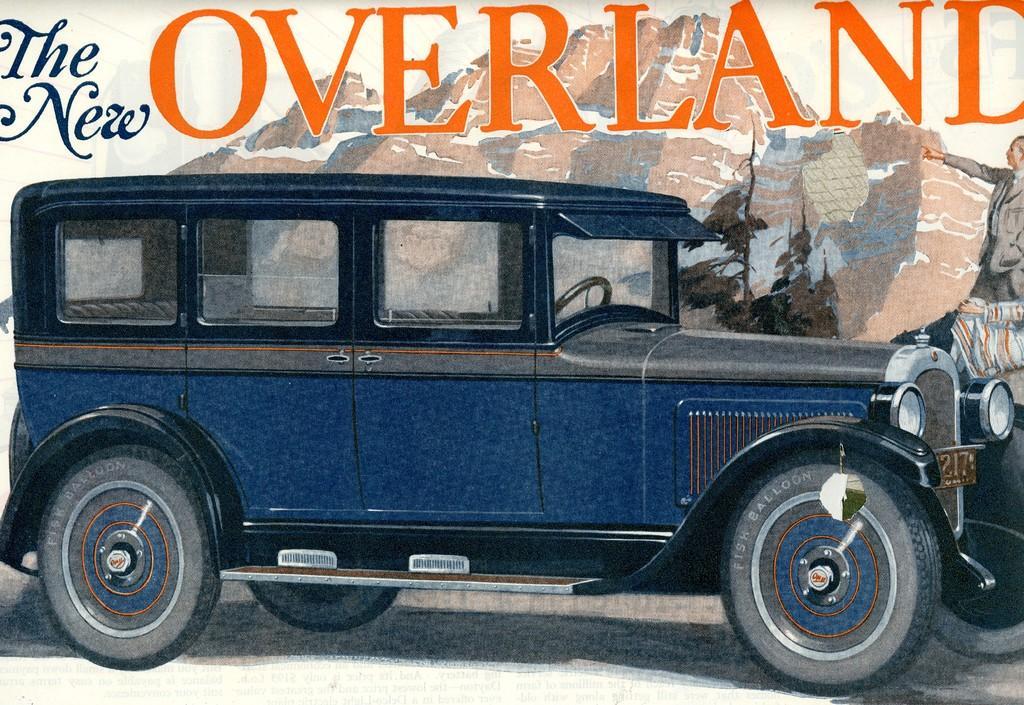In one or two sentences, can you explain what this image depicts? This image consists of a poster. On the poster there is a painting of a vehicle on the road. In the background there are few rocks. On the right side there is a person. At the top of the image I can see some text. 